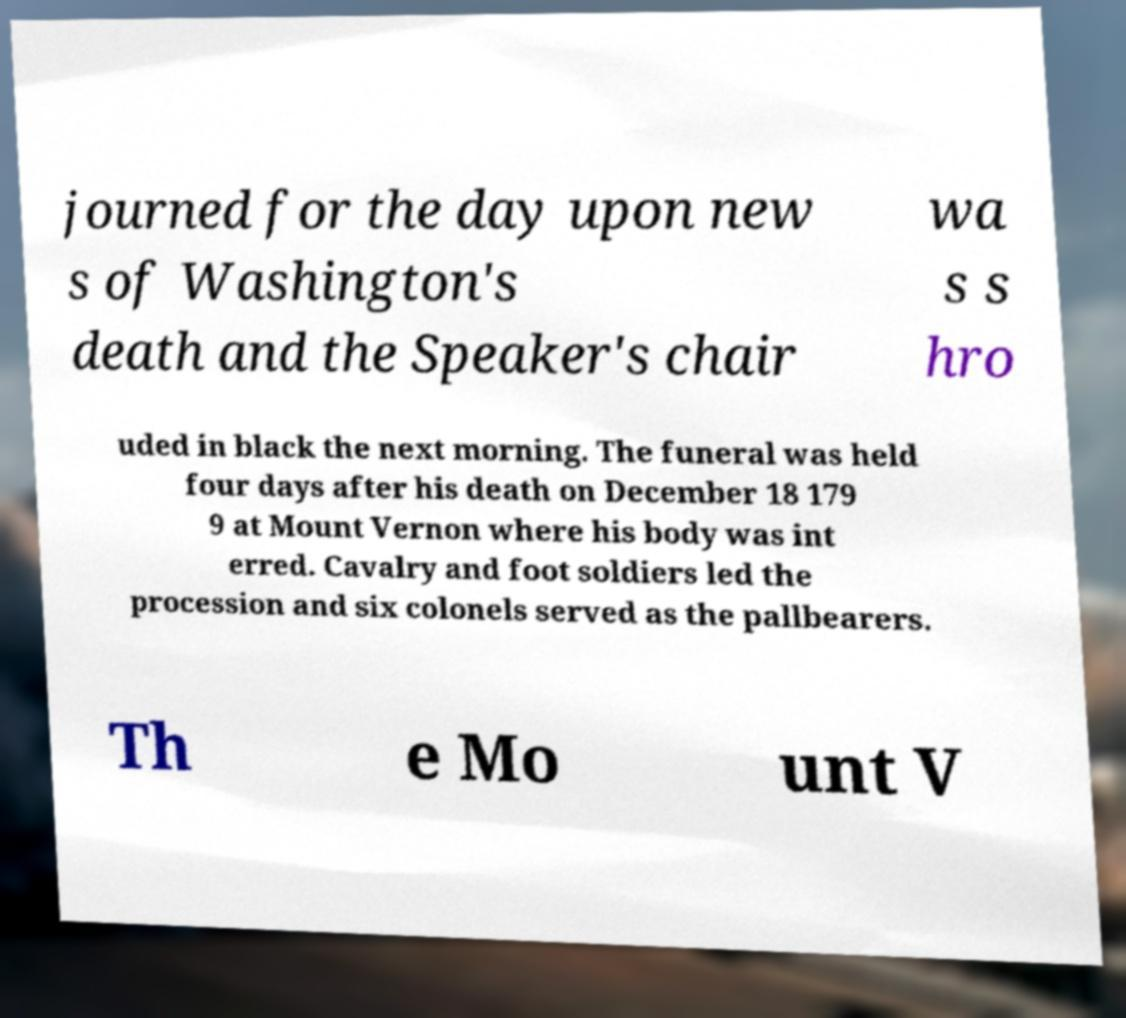Could you assist in decoding the text presented in this image and type it out clearly? journed for the day upon new s of Washington's death and the Speaker's chair wa s s hro uded in black the next morning. The funeral was held four days after his death on December 18 179 9 at Mount Vernon where his body was int erred. Cavalry and foot soldiers led the procession and six colonels served as the pallbearers. Th e Mo unt V 